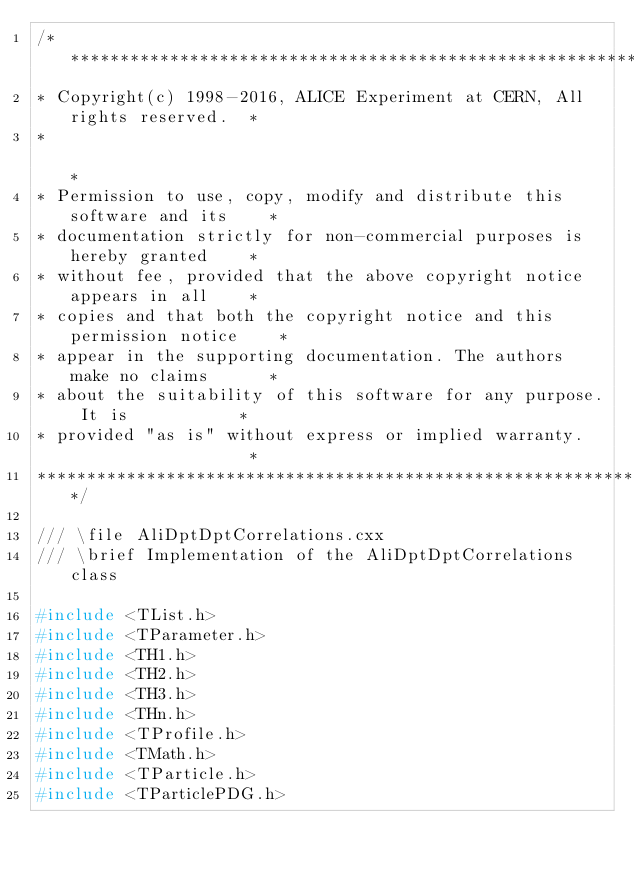<code> <loc_0><loc_0><loc_500><loc_500><_C++_>/**************************************************************************
* Copyright(c) 1998-2016, ALICE Experiment at CERN, All rights reserved.  *
*                                                                         *
* Permission to use, copy, modify and distribute this software and its    *
* documentation strictly for non-commercial purposes is hereby granted    *
* without fee, provided that the above copyright notice appears in all    *
* copies and that both the copyright notice and this permission notice    *
* appear in the supporting documentation. The authors make no claims      *
* about the suitability of this software for any purpose. It is           *
* provided "as is" without express or implied warranty.                   *
**************************************************************************/

/// \file AliDptDptCorrelations.cxx
/// \brief Implementation of the AliDptDptCorrelations class

#include <TList.h>
#include <TParameter.h>
#include <TH1.h>
#include <TH2.h>
#include <TH3.h>
#include <THn.h>
#include <TProfile.h>
#include <TMath.h>
#include <TParticle.h>
#include <TParticlePDG.h></code> 